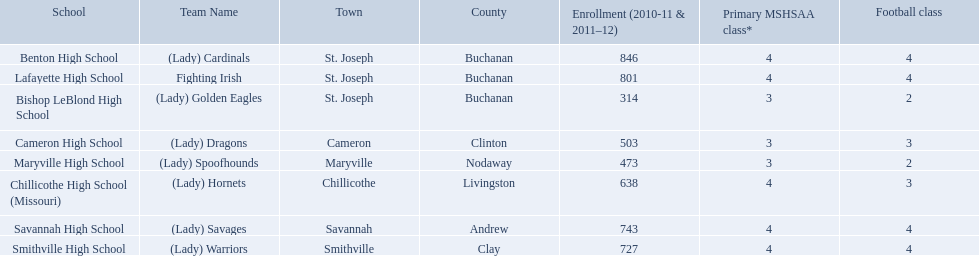What is the lowest number of students enrolled at a school as listed here? 314. What school has 314 students enrolled? Bishop LeBlond High School. 